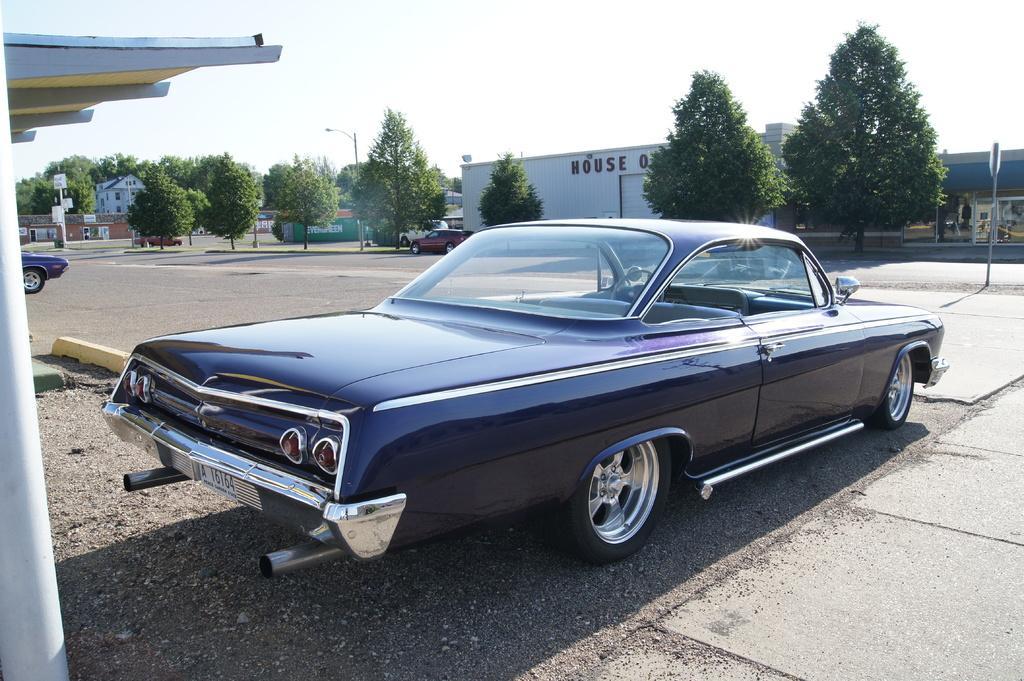Can you describe this image briefly? In the middle of this image, there is a vehicle parked. Besides this vehicle, there is a road. On the left side, there is a pipe. On the right side, there are trees, poles, buildings and vehicles on the road. In the background, there are poles, trees, buildings and there are clouds in the sky. 